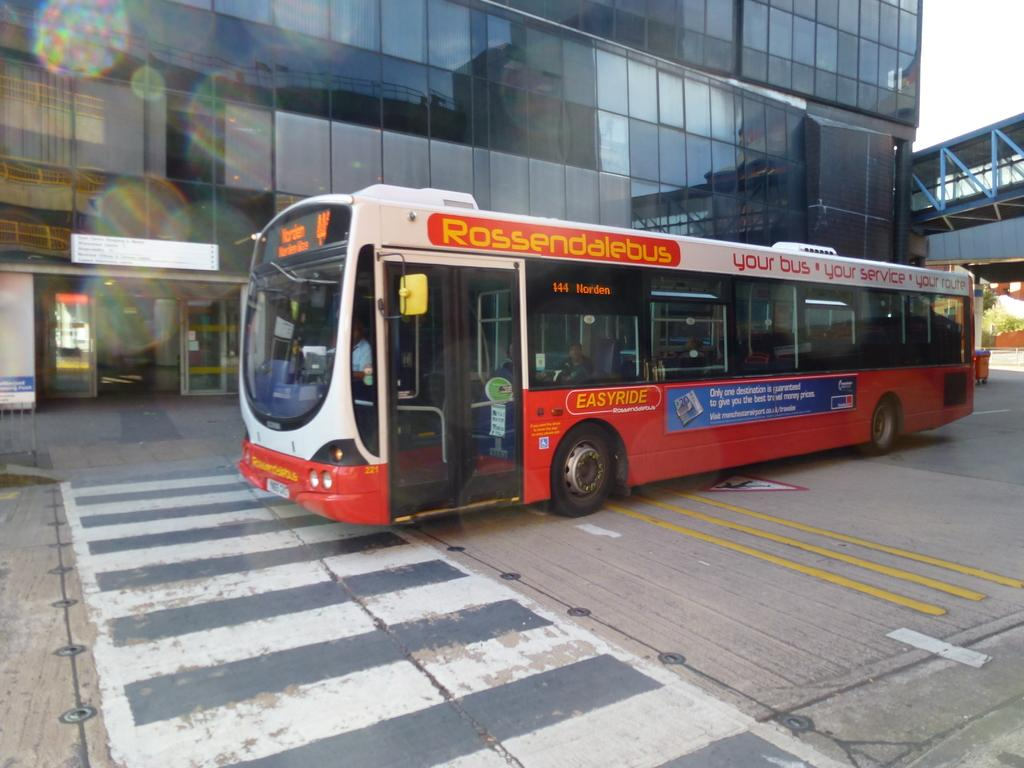Provide a one-sentence caption for the provided image. A Rossendalebus is on a city street near a crosswalk. 